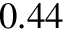Convert formula to latex. <formula><loc_0><loc_0><loc_500><loc_500>0 . 4 4</formula> 